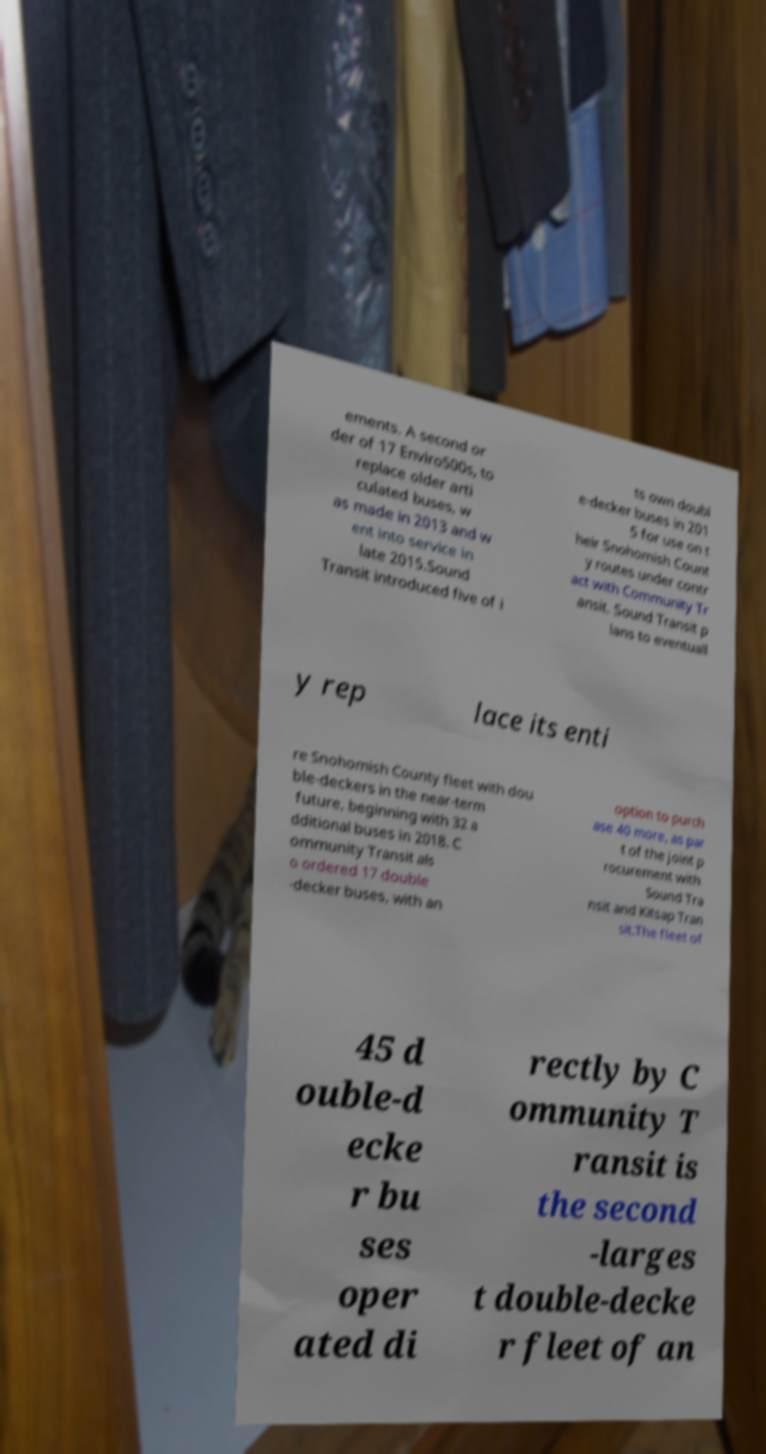There's text embedded in this image that I need extracted. Can you transcribe it verbatim? ements. A second or der of 17 Enviro500s, to replace older arti culated buses, w as made in 2013 and w ent into service in late 2015.Sound Transit introduced five of i ts own doubl e-decker buses in 201 5 for use on t heir Snohomish Count y routes under contr act with Community Tr ansit. Sound Transit p lans to eventuall y rep lace its enti re Snohomish County fleet with dou ble-deckers in the near-term future, beginning with 32 a dditional buses in 2018. C ommunity Transit als o ordered 17 double -decker buses, with an option to purch ase 40 more, as par t of the joint p rocurement with Sound Tra nsit and Kitsap Tran sit.The fleet of 45 d ouble-d ecke r bu ses oper ated di rectly by C ommunity T ransit is the second -larges t double-decke r fleet of an 